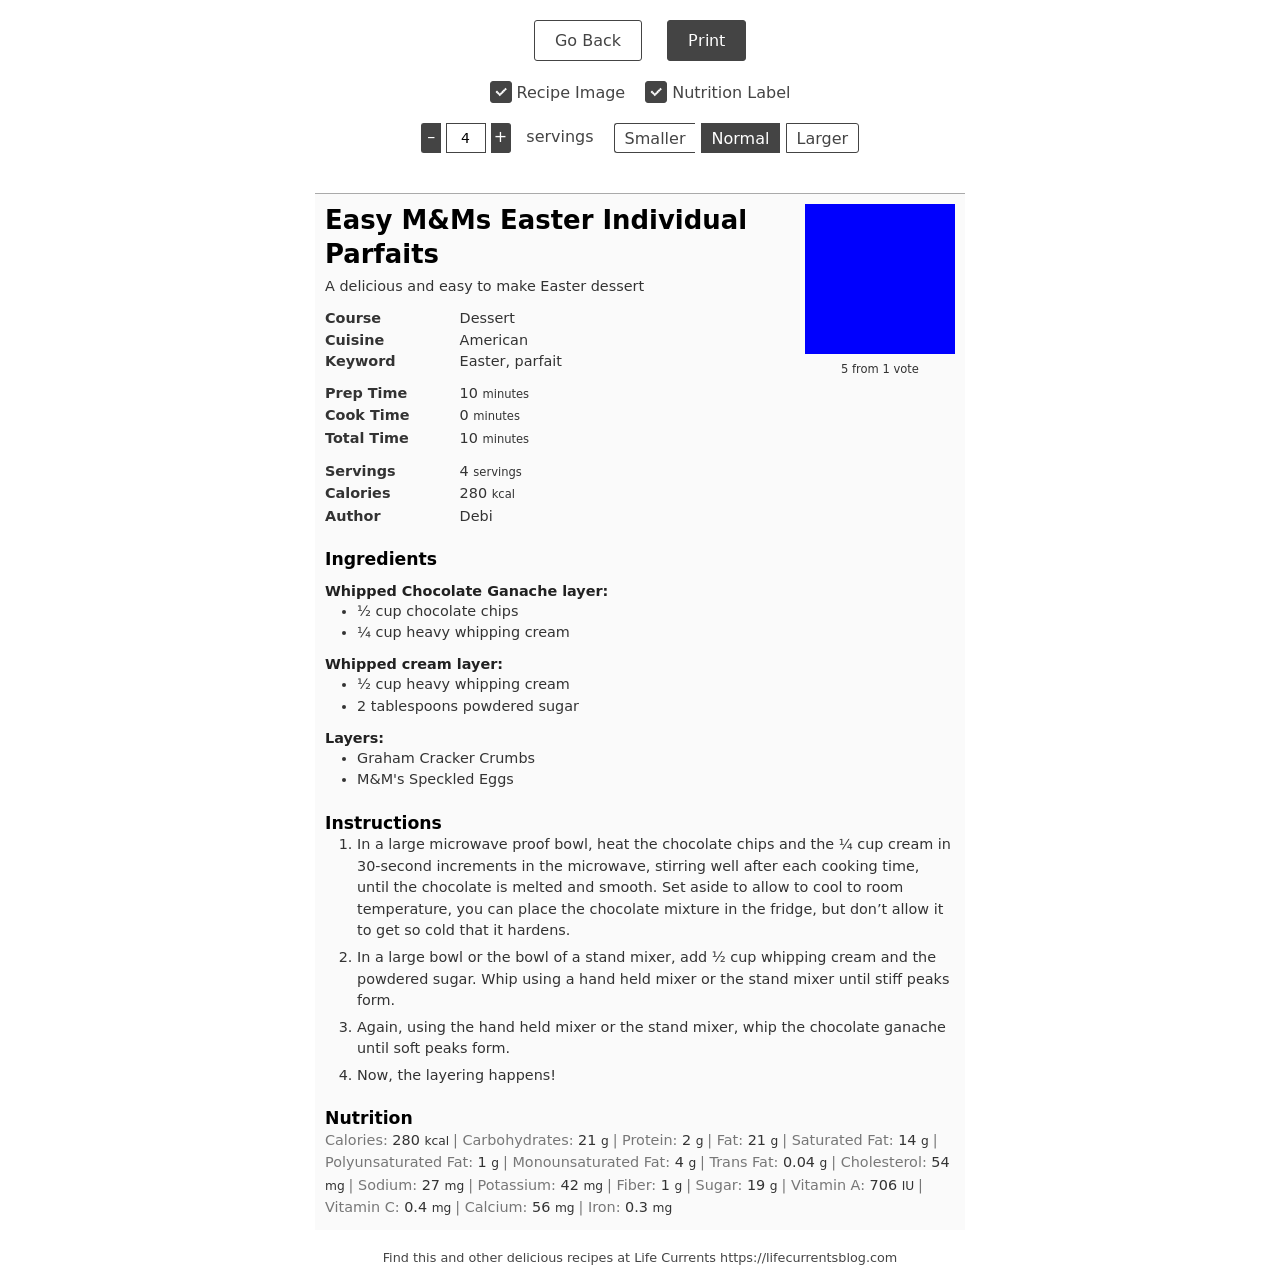Could you suggest an alternative topping for the M&Ms Speckled Eggs used in this recipe? Certainly! For a twist, you might consider using mini chocolate eggs or jelly beans as a colorful and delightful alternative. Dusted edible glitter or crushed pastel candies could also add a festive touch for Easter. 